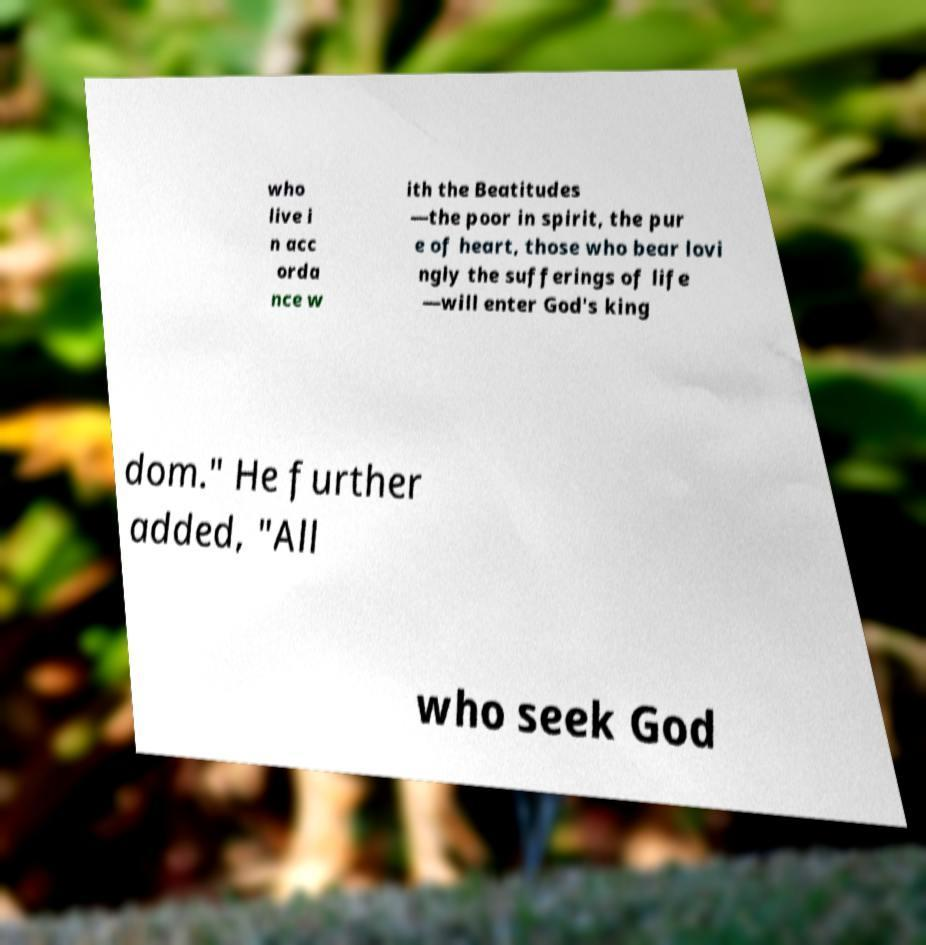Please identify and transcribe the text found in this image. who live i n acc orda nce w ith the Beatitudes —the poor in spirit, the pur e of heart, those who bear lovi ngly the sufferings of life —will enter God's king dom." He further added, "All who seek God 